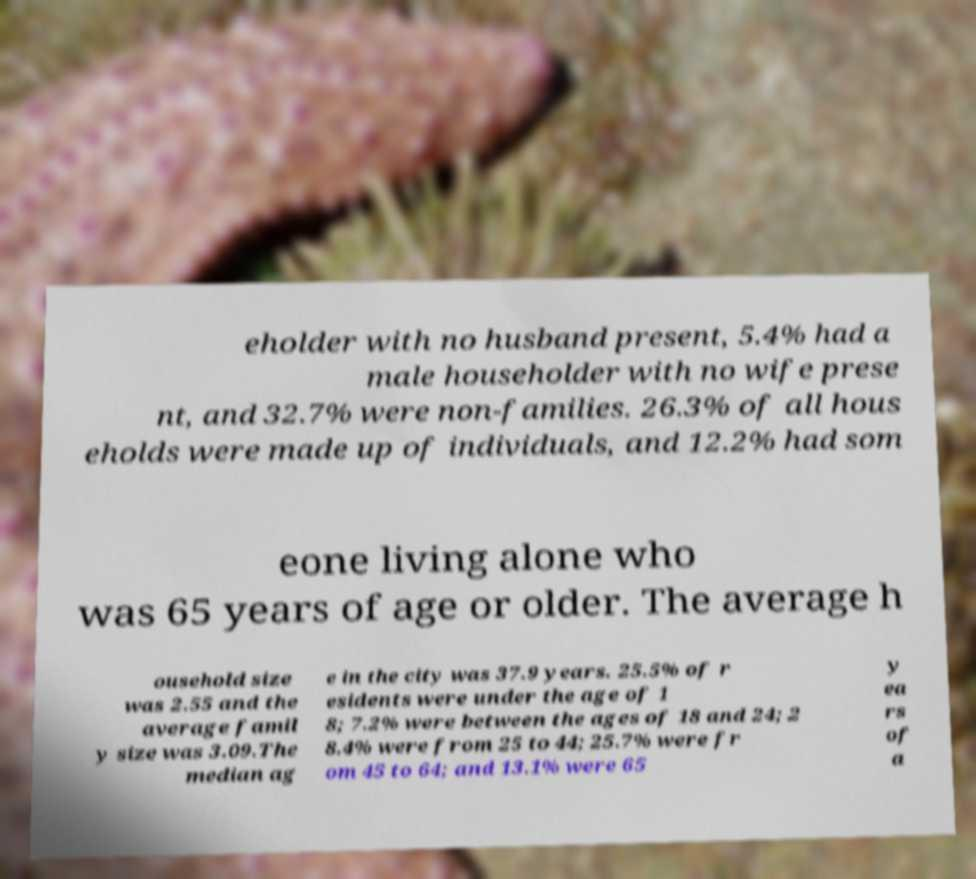Could you assist in decoding the text presented in this image and type it out clearly? eholder with no husband present, 5.4% had a male householder with no wife prese nt, and 32.7% were non-families. 26.3% of all hous eholds were made up of individuals, and 12.2% had som eone living alone who was 65 years of age or older. The average h ousehold size was 2.55 and the average famil y size was 3.09.The median ag e in the city was 37.9 years. 25.5% of r esidents were under the age of 1 8; 7.2% were between the ages of 18 and 24; 2 8.4% were from 25 to 44; 25.7% were fr om 45 to 64; and 13.1% were 65 y ea rs of a 